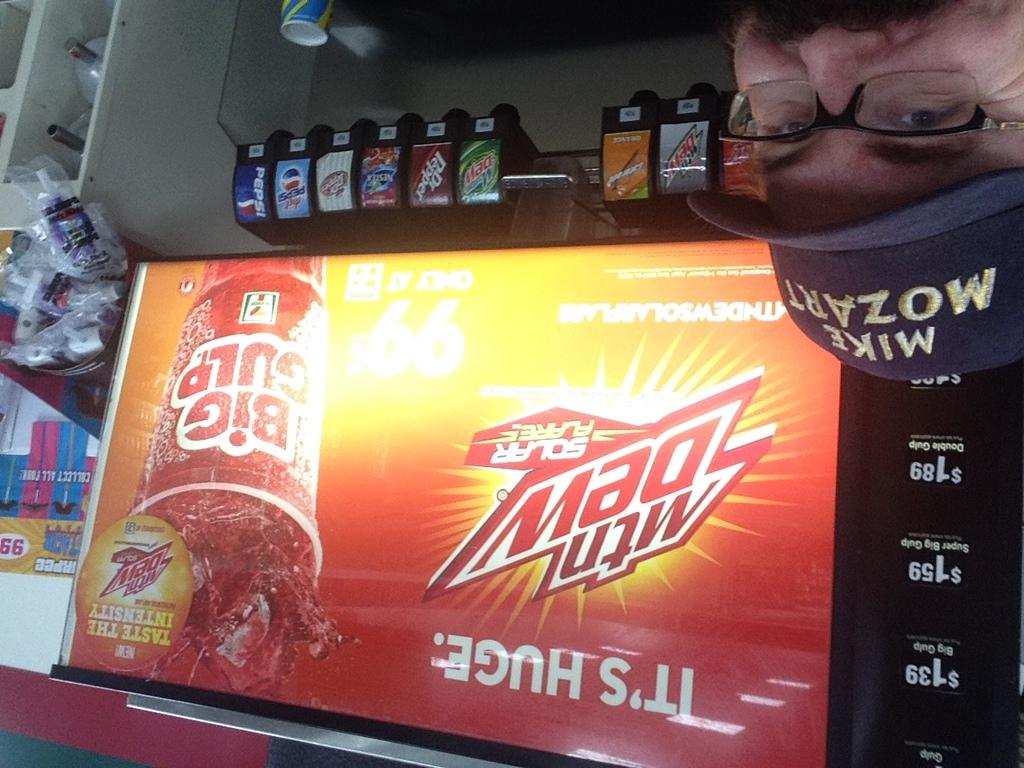<image>
Give a short and clear explanation of the subsequent image. An upside down shot of a MTN Dew dispensing machine. 